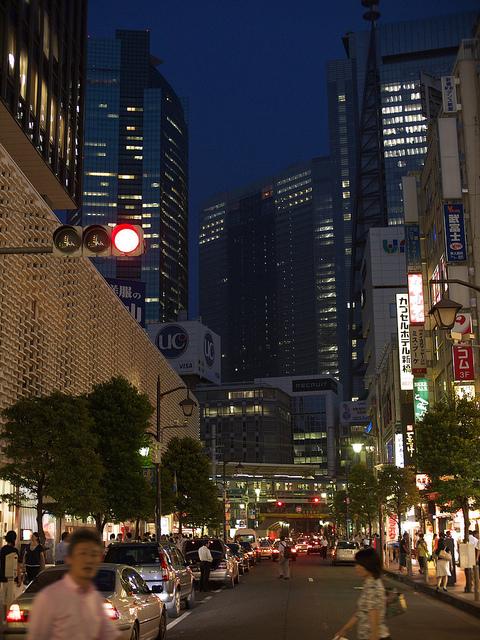Are most of the lights on or off in the building on the left?
Give a very brief answer. Off. What are those buildings called?
Short answer required. Skyscrapers. What color is the signal light?
Keep it brief. Red. Is this an urban scene?
Concise answer only. Yes. 